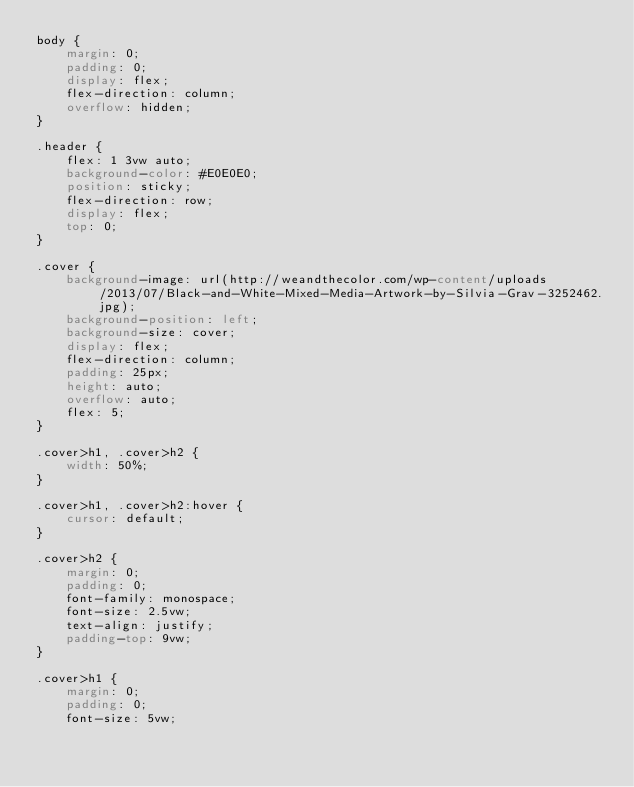<code> <loc_0><loc_0><loc_500><loc_500><_CSS_>body {
    margin: 0;
    padding: 0;
    display: flex;
    flex-direction: column;
    overflow: hidden;
}

.header {
    flex: 1 3vw auto;
    background-color: #E0E0E0;
    position: sticky;
    flex-direction: row;
    display: flex;
    top: 0;
}

.cover {
    background-image: url(http://weandthecolor.com/wp-content/uploads/2013/07/Black-and-White-Mixed-Media-Artwork-by-Silvia-Grav-3252462.jpg);
    background-position: left;
    background-size: cover;
    display: flex;
    flex-direction: column;
    padding: 25px;
    height: auto;
    overflow: auto;
    flex: 5;
}

.cover>h1, .cover>h2 {
    width: 50%;
}

.cover>h1, .cover>h2:hover {
    cursor: default;
}

.cover>h2 {
    margin: 0;
    padding: 0;
    font-family: monospace;
    font-size: 2.5vw;
    text-align: justify;
    padding-top: 9vw;
}

.cover>h1 {
    margin: 0;
    padding: 0;
    font-size: 5vw;</code> 